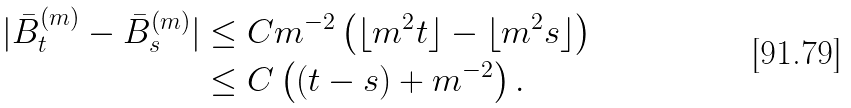Convert formula to latex. <formula><loc_0><loc_0><loc_500><loc_500>| \bar { B } ^ { ( m ) } _ { t } - \bar { B } ^ { ( m ) } _ { s } | & \leq C m ^ { - 2 } \left ( \lfloor m ^ { 2 } t \rfloor - \lfloor m ^ { 2 } s \rfloor \right ) \\ & \leq C \left ( ( t - s ) + m ^ { - 2 } \right ) .</formula> 